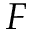Convert formula to latex. <formula><loc_0><loc_0><loc_500><loc_500>F</formula> 